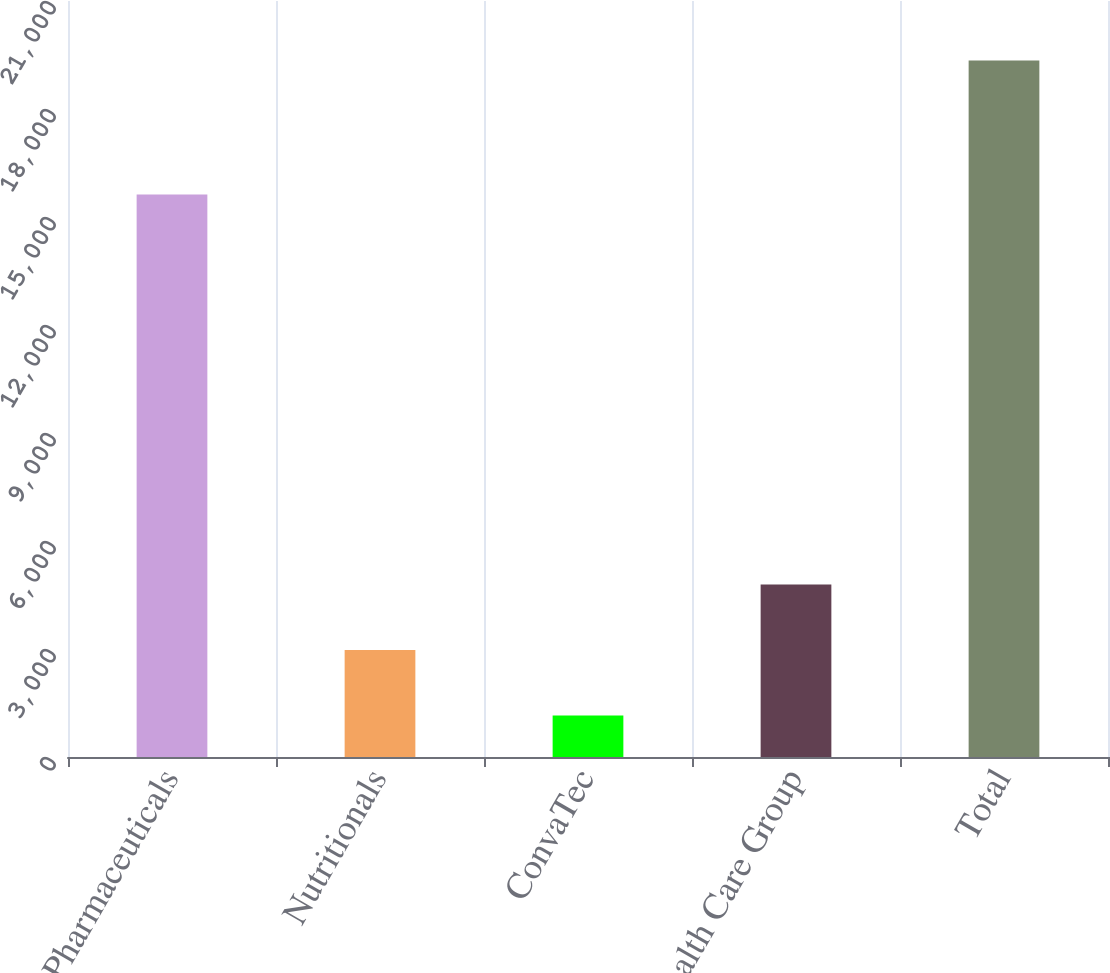Convert chart to OTSL. <chart><loc_0><loc_0><loc_500><loc_500><bar_chart><fcel>Pharmaceuticals<fcel>Nutritionals<fcel>ConvaTec<fcel>Health Care Group<fcel>Total<nl><fcel>15622<fcel>2974.3<fcel>1155<fcel>4793.6<fcel>19348<nl></chart> 